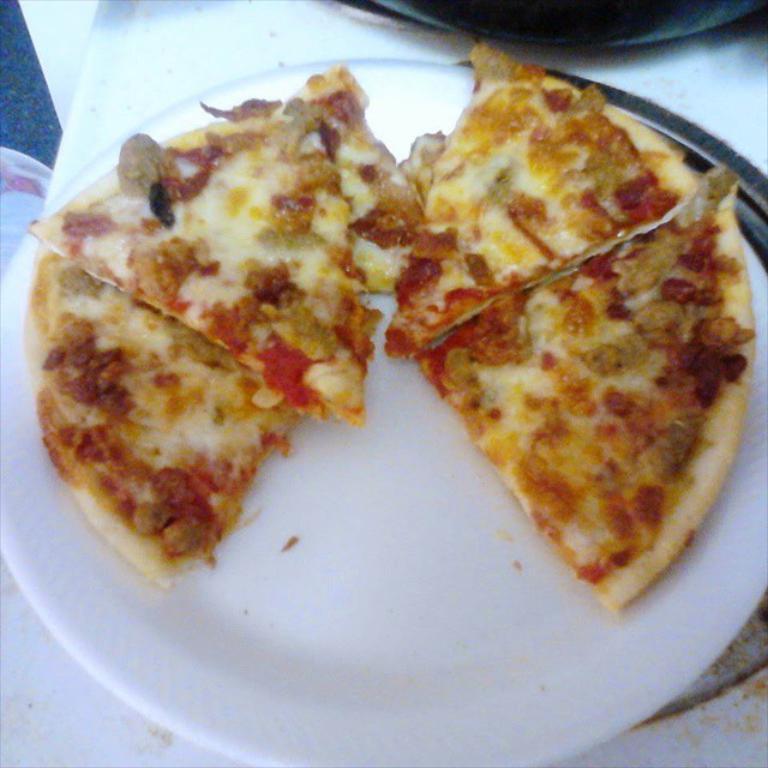Please provide a concise description of this image. In this picture we can see pizza slices in the plate and this plate is on the platform. 